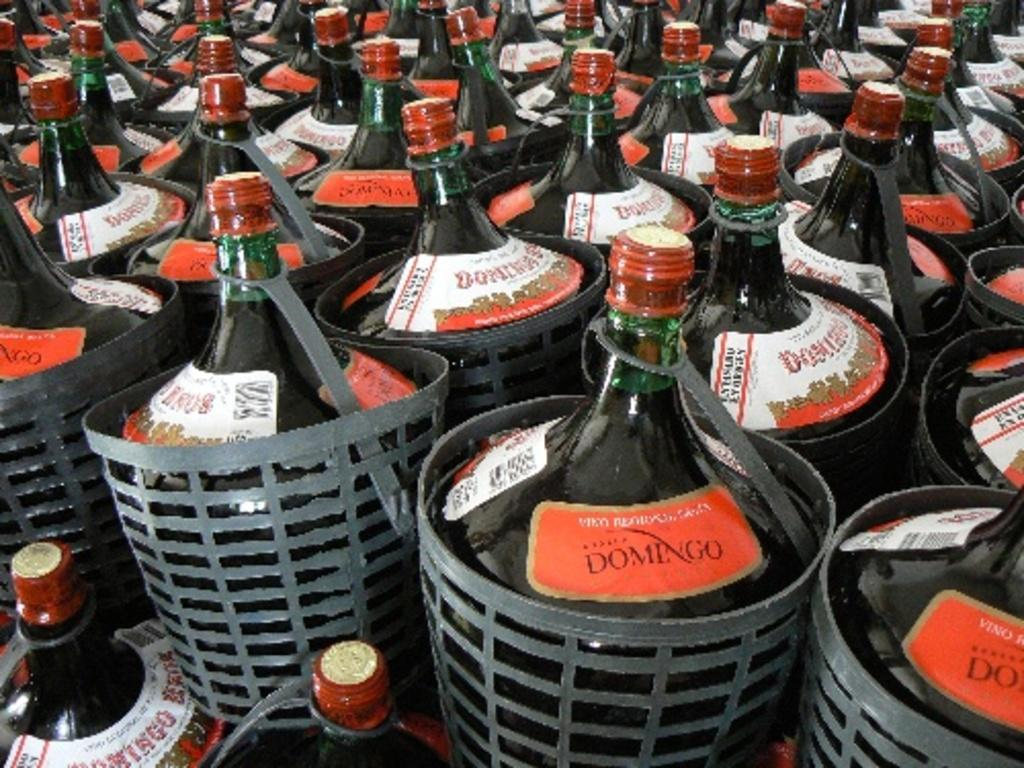<image>
Present a compact description of the photo's key features. Many bottles of Domingo sit in baskets crowded together. 